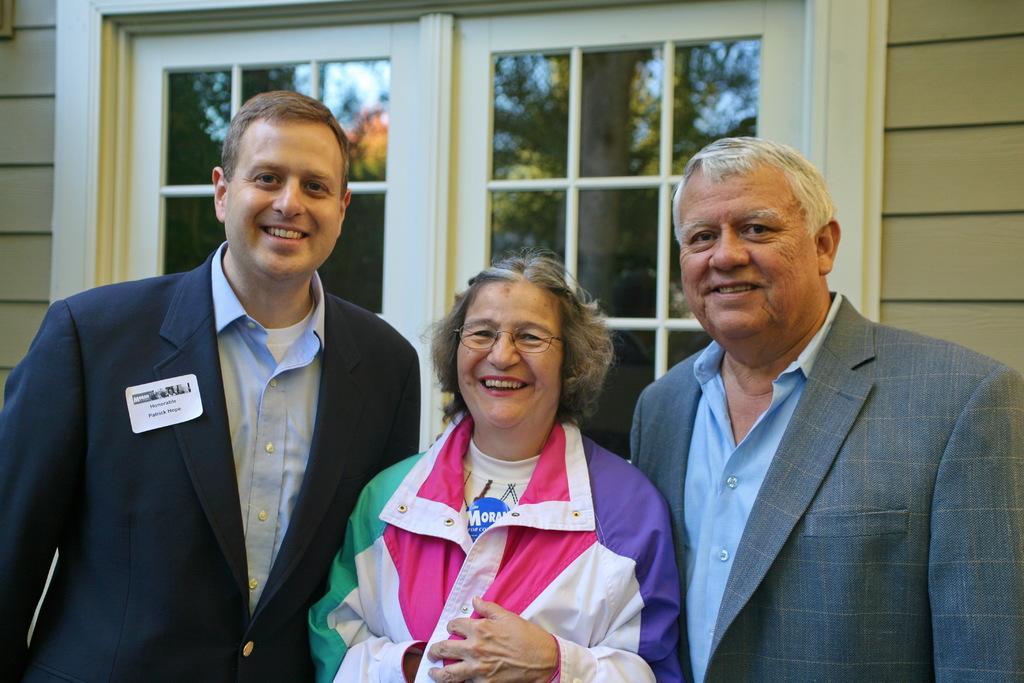Can you describe this image briefly? In this image we can see three persons. One woman is wearing spectacles. In the background, we can see a building with doors and group of trees. 